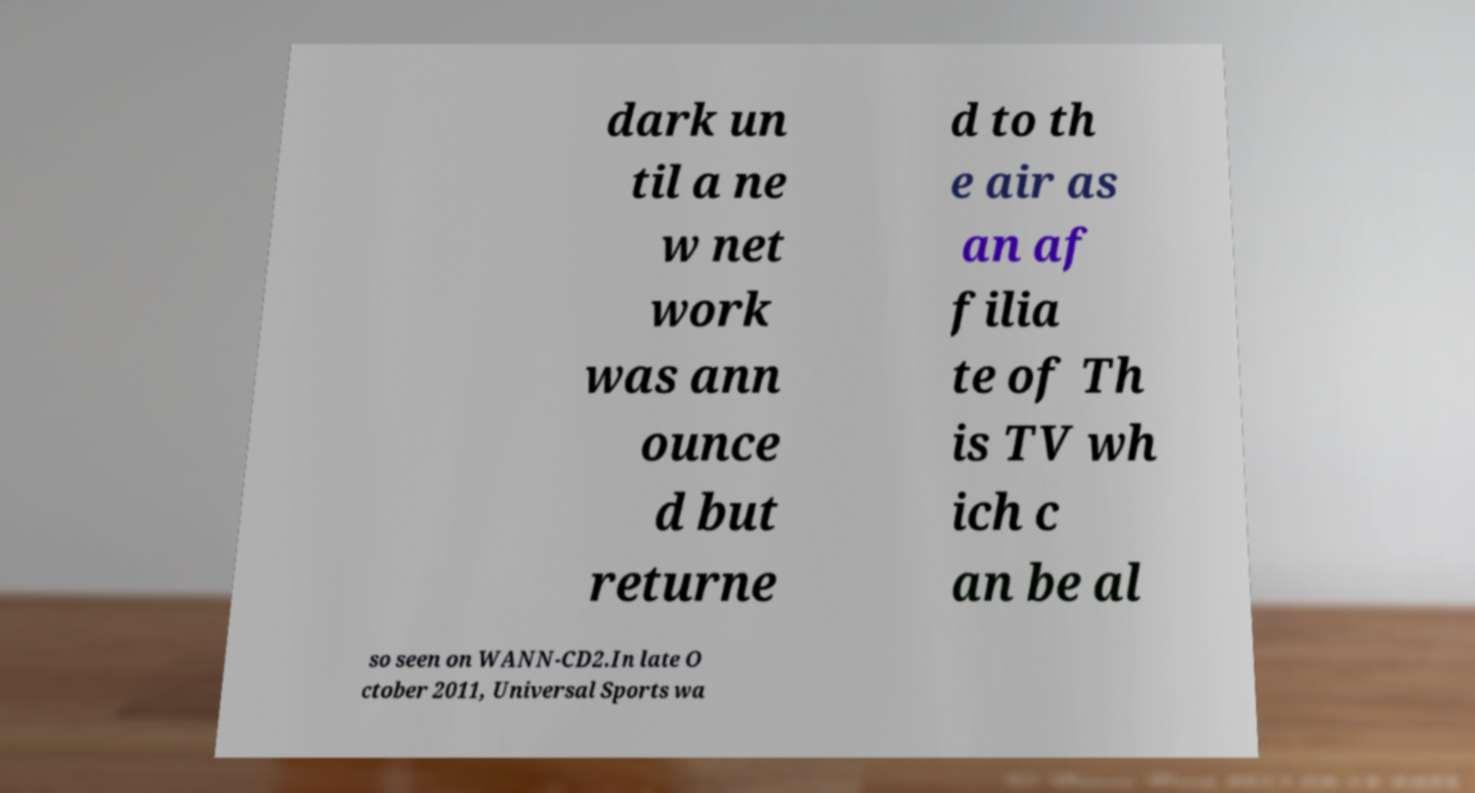Please read and relay the text visible in this image. What does it say? dark un til a ne w net work was ann ounce d but returne d to th e air as an af filia te of Th is TV wh ich c an be al so seen on WANN-CD2.In late O ctober 2011, Universal Sports wa 